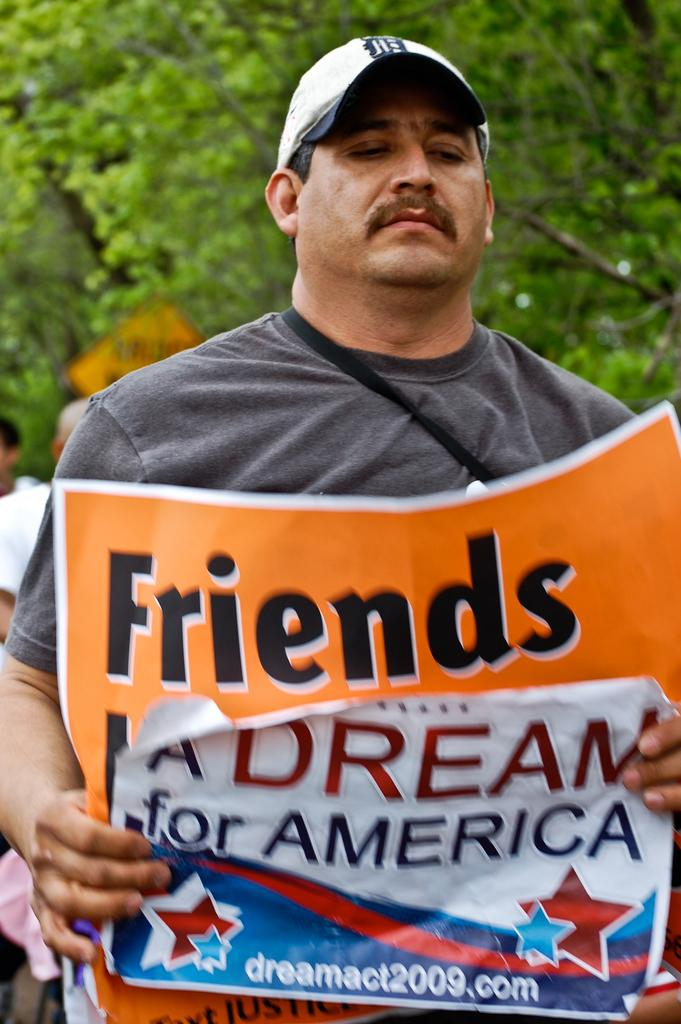<image>
Share a concise interpretation of the image provided. A man holds up an orange sign that says "friends" 